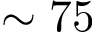<formula> <loc_0><loc_0><loc_500><loc_500>\sim 7 5</formula> 